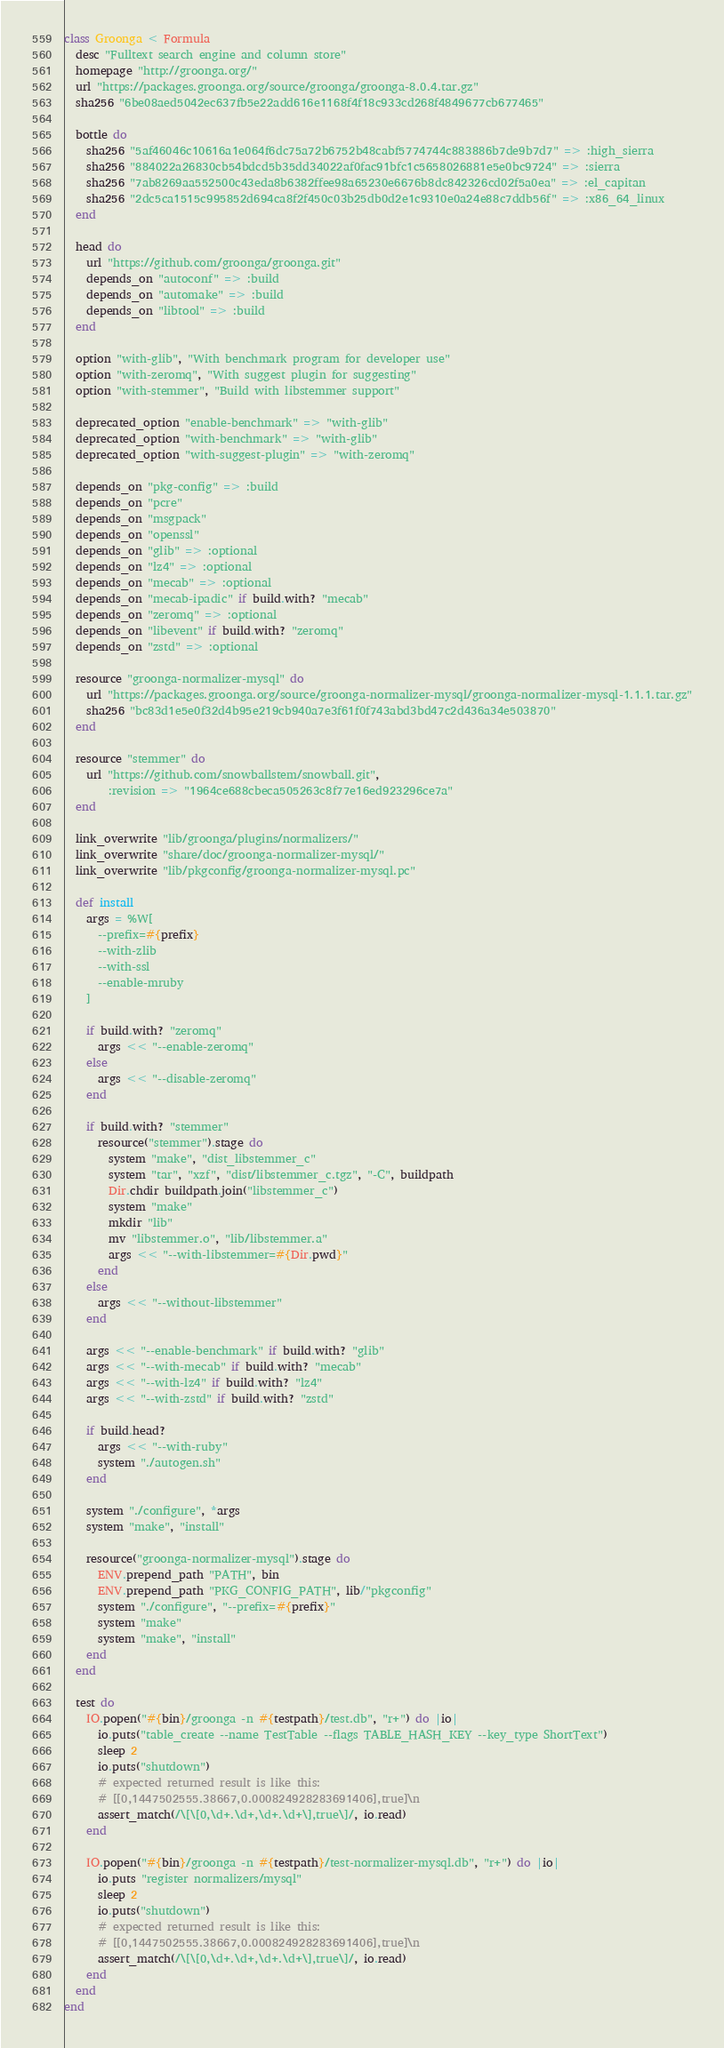<code> <loc_0><loc_0><loc_500><loc_500><_Ruby_>class Groonga < Formula
  desc "Fulltext search engine and column store"
  homepage "http://groonga.org/"
  url "https://packages.groonga.org/source/groonga/groonga-8.0.4.tar.gz"
  sha256 "6be08aed5042ec637fb5e22add616e1168f4f18c933cd268f4849677cb677465"

  bottle do
    sha256 "5af46046c10616a1e064f6dc75a72b6752b48cabf5774744c883886b7de9b7d7" => :high_sierra
    sha256 "884022a26830cb54bdcd5b35dd34022af0fac91bfc1c5658026881e5e0bc9724" => :sierra
    sha256 "7ab8269aa552500c43eda8b6382ffee98a65230e6676b8dc842326cd02f5a0ea" => :el_capitan
    sha256 "2dc5ca1515c995852d694ca8f2f450c03b25db0d2e1c9310e0a24e88c7ddb56f" => :x86_64_linux
  end

  head do
    url "https://github.com/groonga/groonga.git"
    depends_on "autoconf" => :build
    depends_on "automake" => :build
    depends_on "libtool" => :build
  end

  option "with-glib", "With benchmark program for developer use"
  option "with-zeromq", "With suggest plugin for suggesting"
  option "with-stemmer", "Build with libstemmer support"

  deprecated_option "enable-benchmark" => "with-glib"
  deprecated_option "with-benchmark" => "with-glib"
  deprecated_option "with-suggest-plugin" => "with-zeromq"

  depends_on "pkg-config" => :build
  depends_on "pcre"
  depends_on "msgpack"
  depends_on "openssl"
  depends_on "glib" => :optional
  depends_on "lz4" => :optional
  depends_on "mecab" => :optional
  depends_on "mecab-ipadic" if build.with? "mecab"
  depends_on "zeromq" => :optional
  depends_on "libevent" if build.with? "zeromq"
  depends_on "zstd" => :optional

  resource "groonga-normalizer-mysql" do
    url "https://packages.groonga.org/source/groonga-normalizer-mysql/groonga-normalizer-mysql-1.1.1.tar.gz"
    sha256 "bc83d1e5e0f32d4b95e219cb940a7e3f61f0f743abd3bd47c2d436a34e503870"
  end

  resource "stemmer" do
    url "https://github.com/snowballstem/snowball.git",
        :revision => "1964ce688cbeca505263c8f77e16ed923296ce7a"
  end

  link_overwrite "lib/groonga/plugins/normalizers/"
  link_overwrite "share/doc/groonga-normalizer-mysql/"
  link_overwrite "lib/pkgconfig/groonga-normalizer-mysql.pc"

  def install
    args = %W[
      --prefix=#{prefix}
      --with-zlib
      --with-ssl
      --enable-mruby
    ]

    if build.with? "zeromq"
      args << "--enable-zeromq"
    else
      args << "--disable-zeromq"
    end

    if build.with? "stemmer"
      resource("stemmer").stage do
        system "make", "dist_libstemmer_c"
        system "tar", "xzf", "dist/libstemmer_c.tgz", "-C", buildpath
        Dir.chdir buildpath.join("libstemmer_c")
        system "make"
        mkdir "lib"
        mv "libstemmer.o", "lib/libstemmer.a"
        args << "--with-libstemmer=#{Dir.pwd}"
      end
    else
      args << "--without-libstemmer"
    end

    args << "--enable-benchmark" if build.with? "glib"
    args << "--with-mecab" if build.with? "mecab"
    args << "--with-lz4" if build.with? "lz4"
    args << "--with-zstd" if build.with? "zstd"

    if build.head?
      args << "--with-ruby"
      system "./autogen.sh"
    end

    system "./configure", *args
    system "make", "install"

    resource("groonga-normalizer-mysql").stage do
      ENV.prepend_path "PATH", bin
      ENV.prepend_path "PKG_CONFIG_PATH", lib/"pkgconfig"
      system "./configure", "--prefix=#{prefix}"
      system "make"
      system "make", "install"
    end
  end

  test do
    IO.popen("#{bin}/groonga -n #{testpath}/test.db", "r+") do |io|
      io.puts("table_create --name TestTable --flags TABLE_HASH_KEY --key_type ShortText")
      sleep 2
      io.puts("shutdown")
      # expected returned result is like this:
      # [[0,1447502555.38667,0.000824928283691406],true]\n
      assert_match(/\[\[0,\d+.\d+,\d+.\d+\],true\]/, io.read)
    end

    IO.popen("#{bin}/groonga -n #{testpath}/test-normalizer-mysql.db", "r+") do |io|
      io.puts "register normalizers/mysql"
      sleep 2
      io.puts("shutdown")
      # expected returned result is like this:
      # [[0,1447502555.38667,0.000824928283691406],true]\n
      assert_match(/\[\[0,\d+.\d+,\d+.\d+\],true\]/, io.read)
    end
  end
end
</code> 